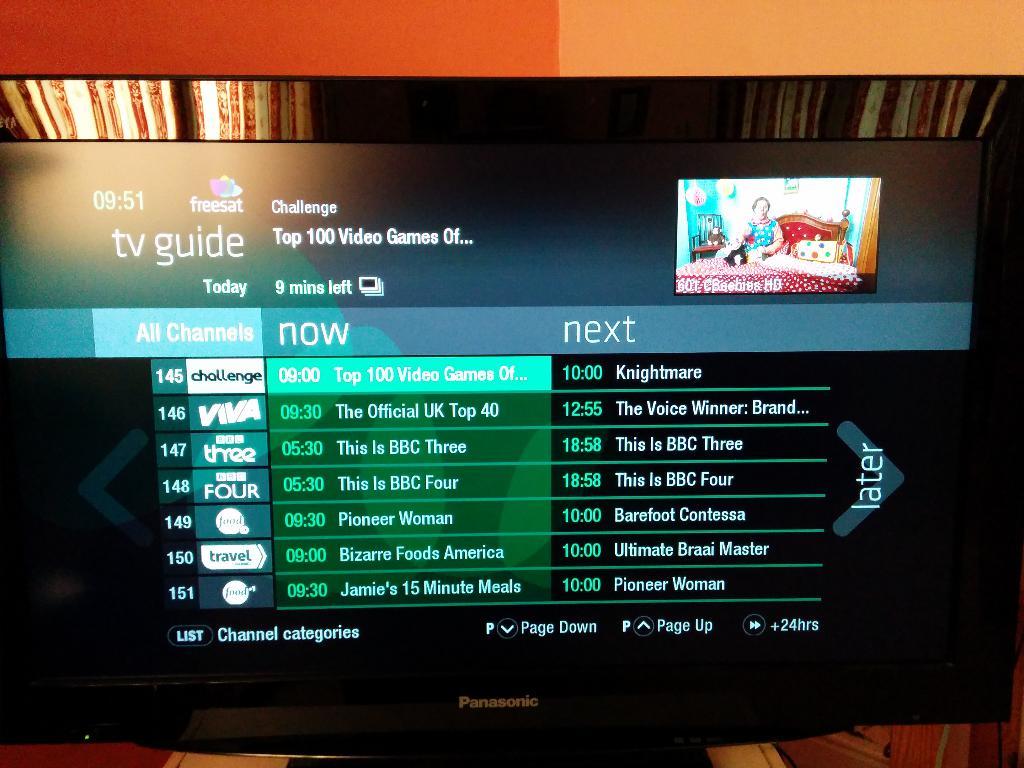What time is displayed?
Provide a short and direct response. 9:51. What is the channel number that is highlighted?
Give a very brief answer. 145. 